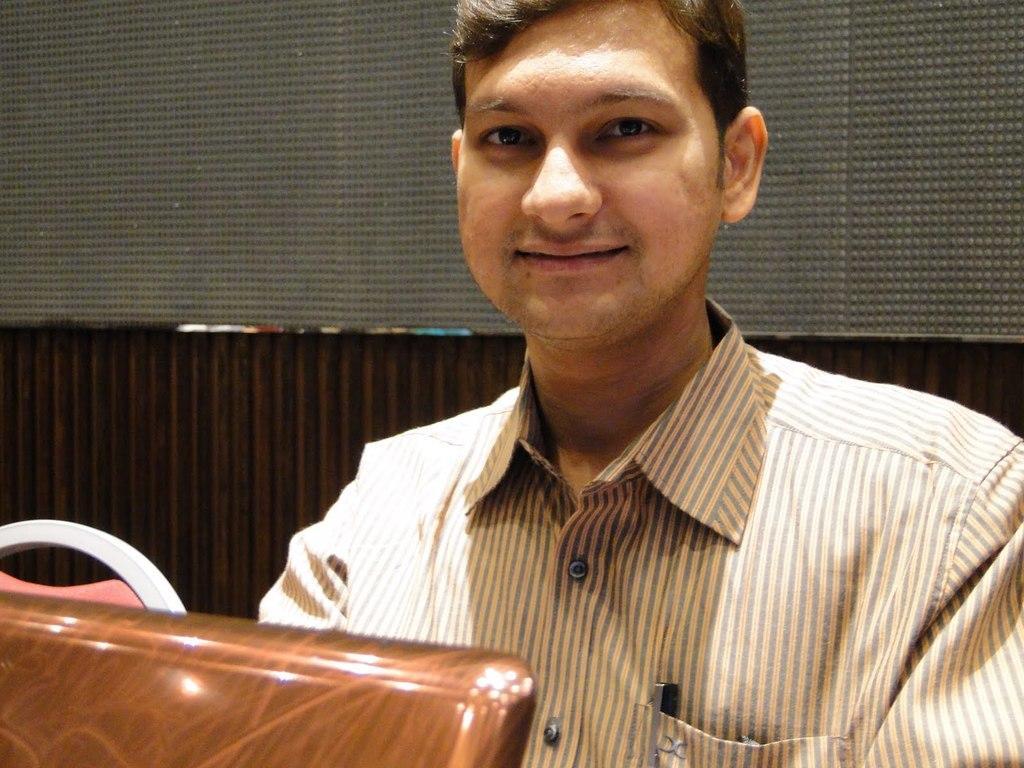In one or two sentences, can you explain what this image depicts? In the image we can see close up picture of a man sitting, wearing clothes and he is smiling. Here we can see the wooden wall and the mesh. 